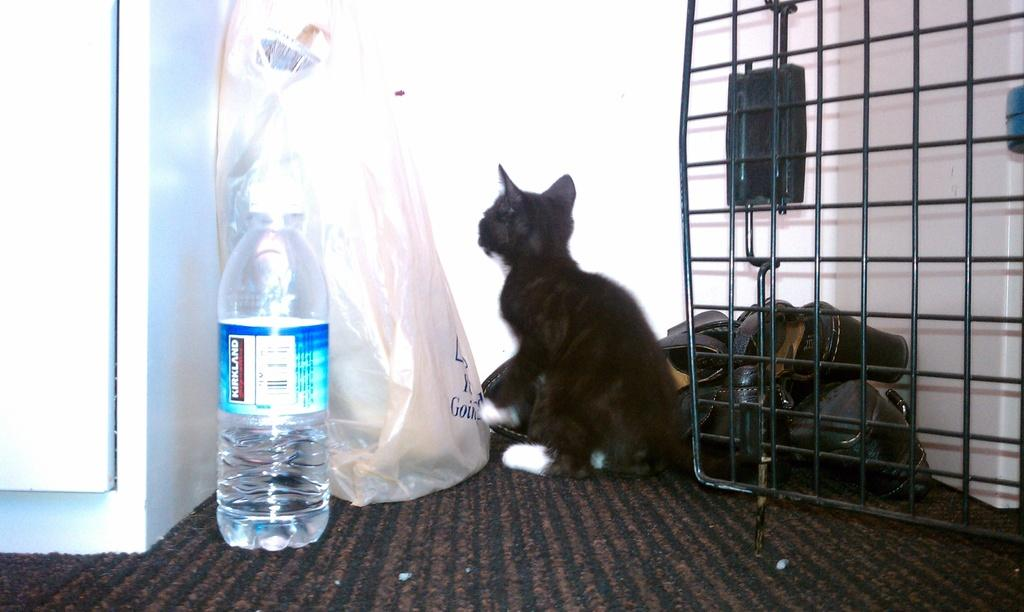What is the color of the wall in the image? The wall in the image is white. What object can be seen on the wall? There is a bottle in the image. What is covering the bottle? There is a cover in the image. What type of animal is present in the image? There is a black color cat in the image. What is the color of the door on the right side of the image? The door on the right side of the image is black. What type of fan is visible in the image? There is no fan present in the image. What type of doctor is attending to the cat in the image? There is no doctor present in the image, and the cat does not appear to be receiving any medical attention. 